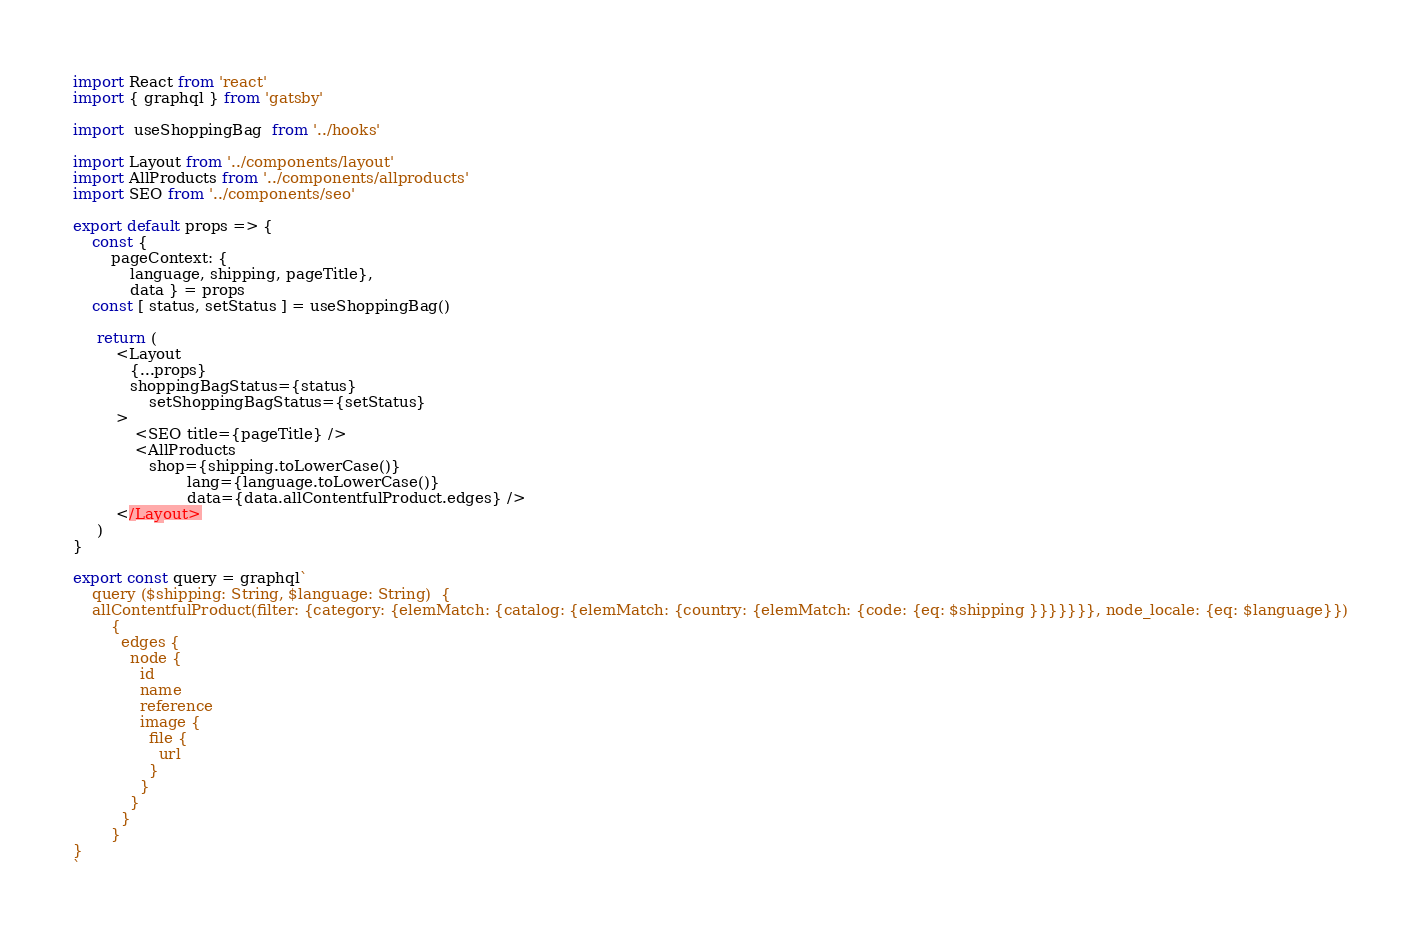Convert code to text. <code><loc_0><loc_0><loc_500><loc_500><_JavaScript_>import React from 'react'
import { graphql } from 'gatsby'

import  useShoppingBag  from '../hooks'

import Layout from '../components/layout'
import AllProducts from '../components/allproducts'
import SEO from '../components/seo'

export default props => {
    const {
        pageContext: {
            language, shipping, pageTitle},
            data } = props
    const [ status, setStatus ] = useShoppingBag()

     return (
         <Layout 
            {...props}
            shoppingBagStatus={status}
		      	setShoppingBagStatus={setStatus}
         >
             <SEO title={pageTitle} />
             <AllProducts 
                shop={shipping.toLowerCase()}
				        lang={language.toLowerCase()}
				        data={data.allContentfulProduct.edges} />
         </Layout>
     )
}

export const query = graphql`
	query ($shipping: String, $language: String)  {
    allContentfulProduct(filter: {category: {elemMatch: {catalog: {elemMatch: {country: {elemMatch: {code: {eq: $shipping }}}}}}}, node_locale: {eq: $language}}) 
        {
          edges {
            node {
              id
              name
              reference
              image {
                file {
                  url
                }
              }
            }
          }
        }
}
`


</code> 